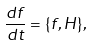<formula> <loc_0><loc_0><loc_500><loc_500>\frac { d f } { d t } = \{ f , H \} ,</formula> 